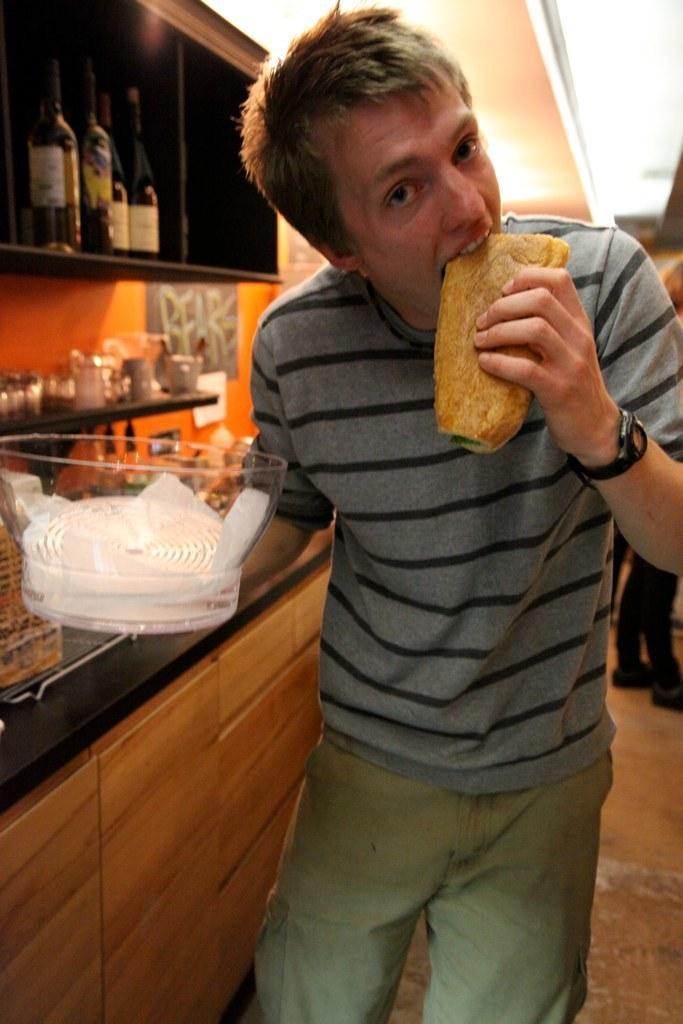How would you summarize this image in a sentence or two? In the foreground we can see a person holding a bowl and eating. On the left there are bottles, glasses, kitchen, table and various kitchen utensils. At the top we can see light and ceiling. On the right we can see a person's legs. 